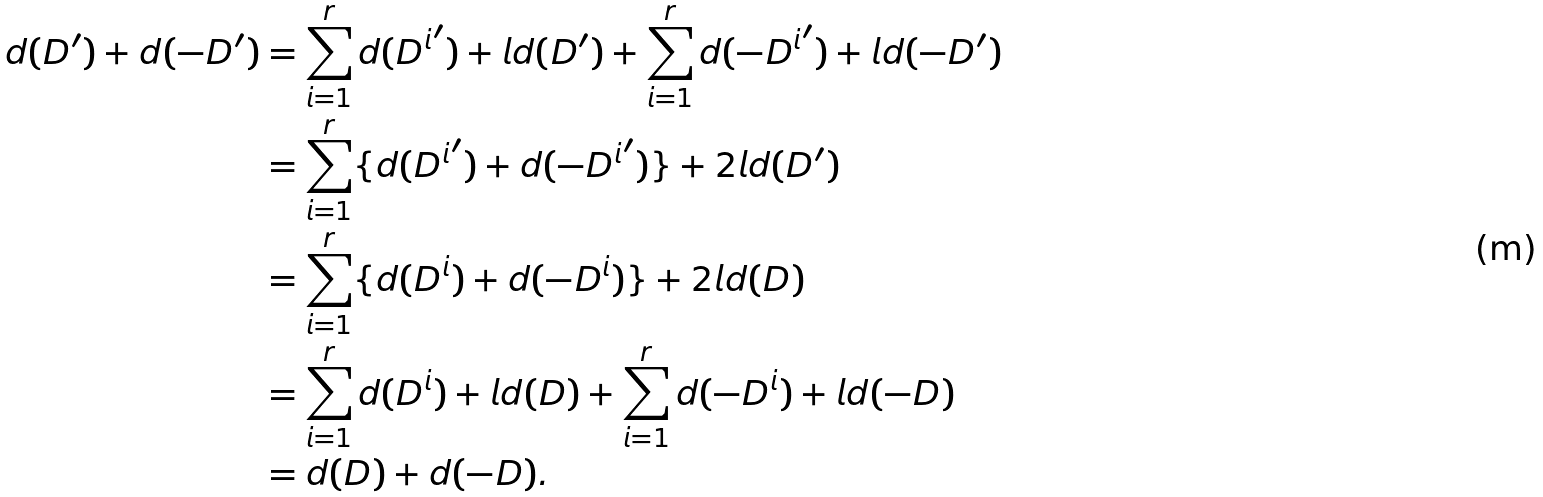Convert formula to latex. <formula><loc_0><loc_0><loc_500><loc_500>d ( D ^ { \prime } ) + d ( - D ^ { \prime } ) & = \sum _ { i = 1 } ^ { r } d ( { D ^ { i } } ^ { \prime } ) + l d ( D ^ { \prime } ) + \sum _ { i = 1 } ^ { r } d ( - { D ^ { i } } ^ { \prime } ) + l d ( - D ^ { \prime } ) \\ & = \sum _ { i = 1 } ^ { r } \{ d ( { D ^ { i } } ^ { \prime } ) + d ( - { D ^ { i } } ^ { \prime } ) \} + 2 l d ( D ^ { \prime } ) \\ & = \sum _ { i = 1 } ^ { r } \{ d ( D ^ { i } ) + d ( - D ^ { i } ) \} + 2 l d ( D ) \\ & = \sum _ { i = 1 } ^ { r } d ( D ^ { i } ) + l d ( D ) + \sum _ { i = 1 } ^ { r } d ( - D ^ { i } ) + l d ( - D ) \\ & = d ( D ) + d ( - D ) .</formula> 